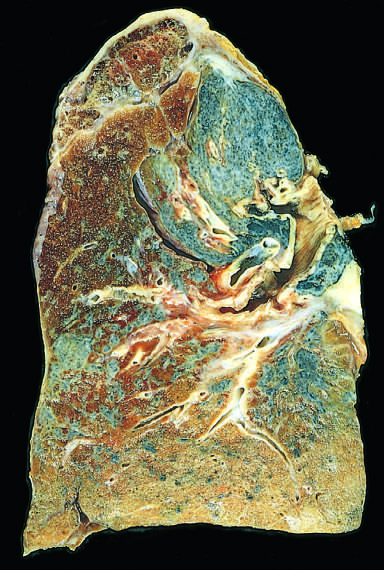what has contracted the upper lobe into a small dark mass?
Answer the question using a single word or phrase. Scarring 